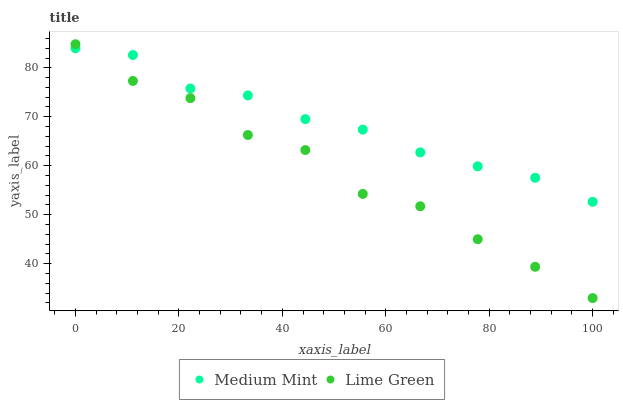Does Lime Green have the minimum area under the curve?
Answer yes or no. Yes. Does Medium Mint have the maximum area under the curve?
Answer yes or no. Yes. Does Lime Green have the maximum area under the curve?
Answer yes or no. No. Is Medium Mint the smoothest?
Answer yes or no. Yes. Is Lime Green the roughest?
Answer yes or no. Yes. Is Lime Green the smoothest?
Answer yes or no. No. Does Lime Green have the lowest value?
Answer yes or no. Yes. Does Lime Green have the highest value?
Answer yes or no. Yes. Does Medium Mint intersect Lime Green?
Answer yes or no. Yes. Is Medium Mint less than Lime Green?
Answer yes or no. No. Is Medium Mint greater than Lime Green?
Answer yes or no. No. 